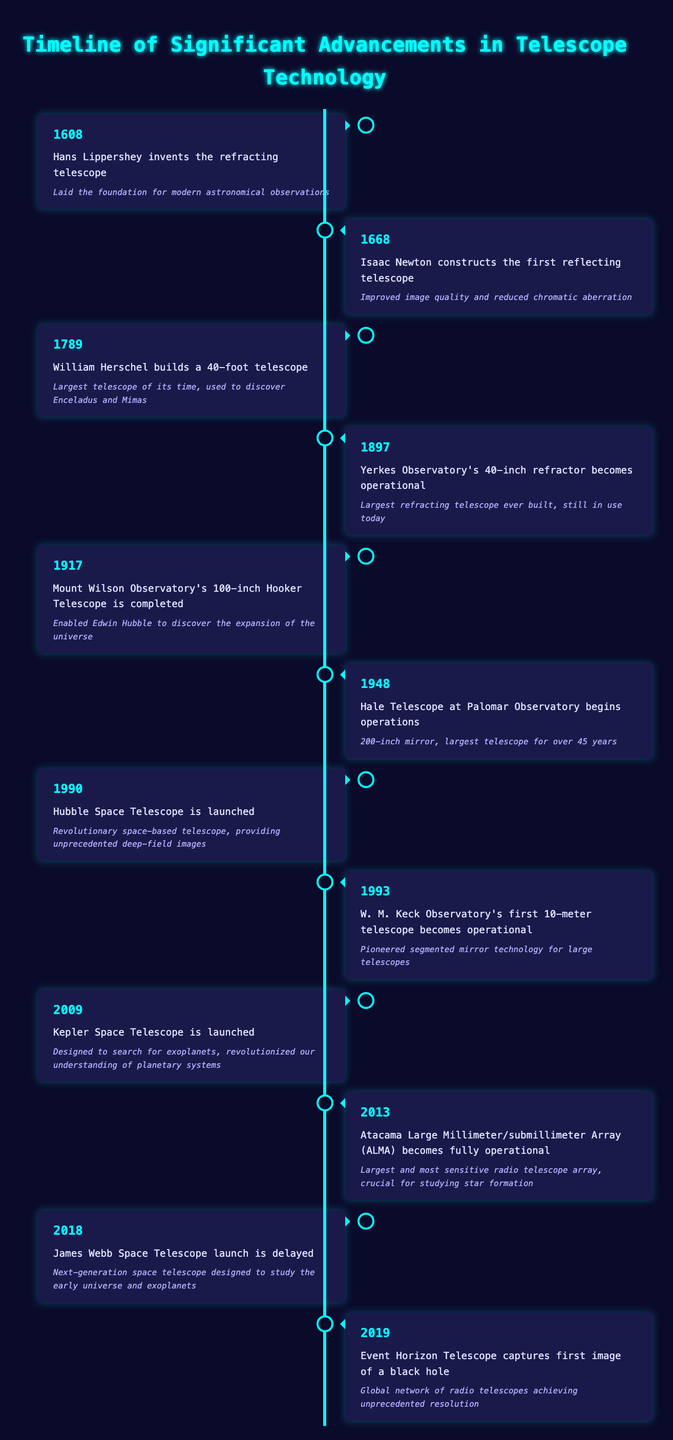What event marked the beginning of telescope technology? The first event listed in the table corresponds to the year 1608 when Hans Lippershey invented the refracting telescope. This invention is described as laying the foundation for modern astronomical observations.
Answer: Hans Lippershey invents the refracting telescope Which telescope was the largest refractor built in the 19th century? According to the timeline, the Yerkes Observatory's 40-inch refractor, which became operational in 1897, is noted as the largest refracting telescope ever built at that time.
Answer: Yerkes Observatory's 40-inch refractor becomes operational How many years passed between the invention of the refracting telescope and the launch of the Hubble Space Telescope? The refracting telescope was invented in 1608, and the Hubble Space Telescope was launched in 1990. The difference in years is 1990 - 1608 = 382 years.
Answer: 382 years True or False: The Hale Telescope was the first to utilize segmented mirror technology. The table states that the W.M. Keck Observatory's first 10-meter telescope, operational in 1993, pioneered segmented mirror technology, which means Hale Telescope did not introduce this technology.
Answer: False What significant discovery was enabled by the Mount Wilson Observatory's 100-inch Hooker Telescope? The timeline specifies that this telescope, completed in 1917, enabled Edwin Hubble to discover the expansion of the universe, marking a significant advancement in our understanding of cosmology.
Answer: Enabled Edwin Hubble to discover the expansion of the universe How many major telescope advancements occurred before the year 2000? By counting the entries in the timeline, there are 8 advancements listed before the year 2000. These are events from 1608 through 1993.
Answer: 8 What was the significance of the Atacama Large Millimeter/submillimeter Array? The significance of the Atacama Large Millimeter/submillimeter Array, which became fully operational in 2013, is described as being critical for studying star formation. This highlights its importance in astrophysical research.
Answer: Crucial for studying star formation In what year did the Event Horizon Telescope successfully capture an image of a black hole? The table indicates that the Event Horizon Telescope captured its first image of a black hole in 2019. This event is significant as it provides evidence for the existence of black holes.
Answer: 2019 What technological advancement was brought forth by the Hubble Space Telescope? The Hubble Space Telescope, launched in 1990, is noted for being a revolutionary space-based telescope, providing unprecedented deep-field images that have significantly advanced our understanding of the universe.
Answer: Revolutionary space-based telescope, providing unprecedented deep-field images 